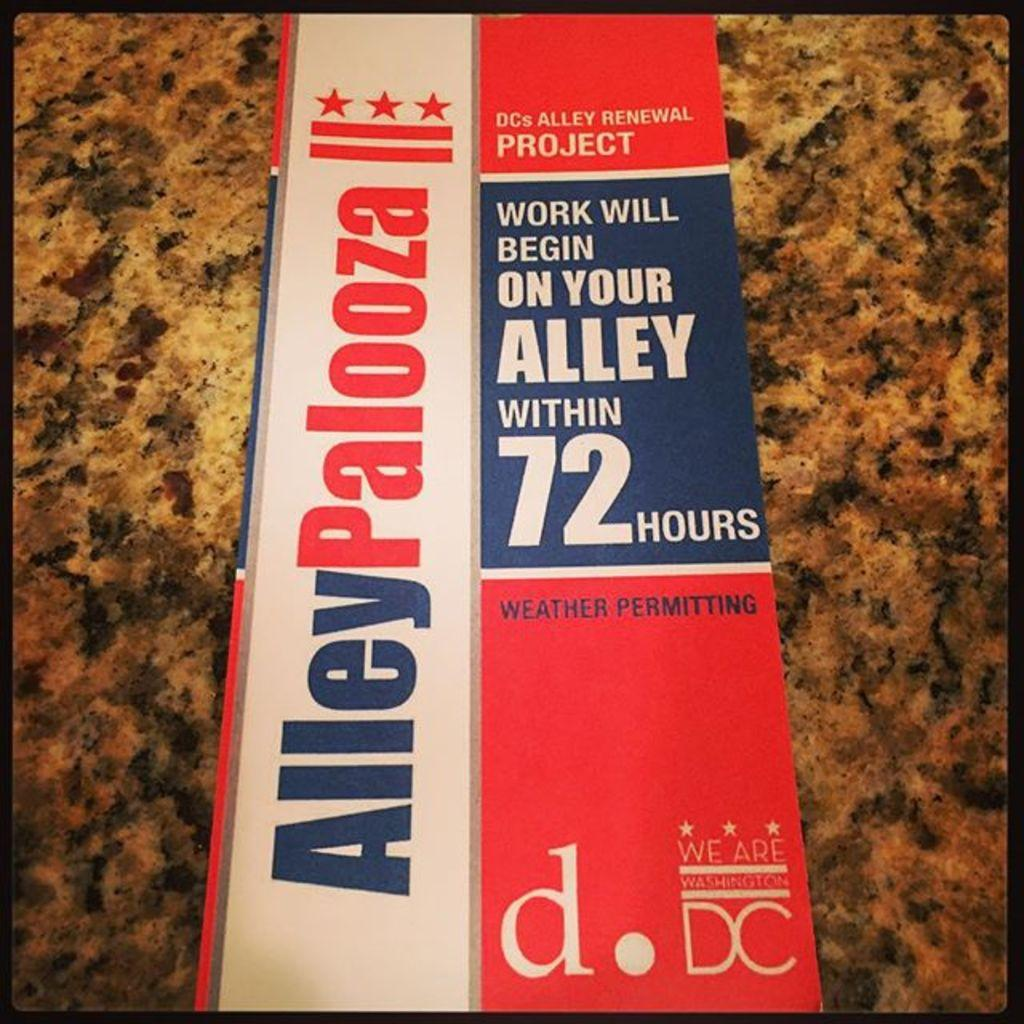<image>
Present a compact description of the photo's key features. A politcal banner for Alley Palooza sits on top of granite countertop 